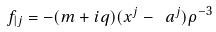Convert formula to latex. <formula><loc_0><loc_0><loc_500><loc_500>f _ { | j } = - ( m + i q ) ( x ^ { j } - \ a ^ { j } ) \rho ^ { - 3 }</formula> 